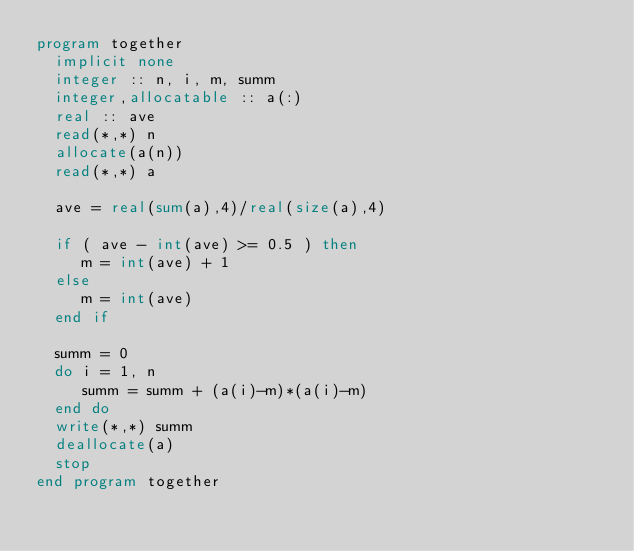<code> <loc_0><loc_0><loc_500><loc_500><_FORTRAN_>program together
  implicit none
  integer :: n, i, m, summ
  integer,allocatable :: a(:)
  real :: ave
  read(*,*) n
  allocate(a(n))
  read(*,*) a

  ave = real(sum(a),4)/real(size(a),4)

  if ( ave - int(ave) >= 0.5 ) then
     m = int(ave) + 1
  else
     m = int(ave)
  end if
  
  summ = 0
  do i = 1, n
     summ = summ + (a(i)-m)*(a(i)-m)
  end do
  write(*,*) summ
  deallocate(a)
  stop
end program together
</code> 